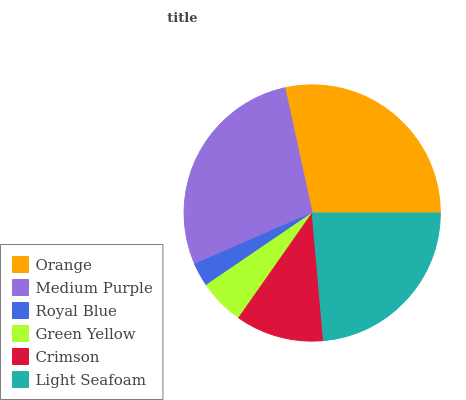Is Royal Blue the minimum?
Answer yes or no. Yes. Is Orange the maximum?
Answer yes or no. Yes. Is Medium Purple the minimum?
Answer yes or no. No. Is Medium Purple the maximum?
Answer yes or no. No. Is Orange greater than Medium Purple?
Answer yes or no. Yes. Is Medium Purple less than Orange?
Answer yes or no. Yes. Is Medium Purple greater than Orange?
Answer yes or no. No. Is Orange less than Medium Purple?
Answer yes or no. No. Is Light Seafoam the high median?
Answer yes or no. Yes. Is Crimson the low median?
Answer yes or no. Yes. Is Medium Purple the high median?
Answer yes or no. No. Is Medium Purple the low median?
Answer yes or no. No. 